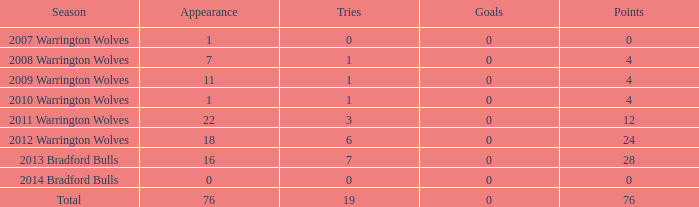What is the average number of tries for the 2008 warrington wolves with a presence exceeding 7? None. Write the full table. {'header': ['Season', 'Appearance', 'Tries', 'Goals', 'Points'], 'rows': [['2007 Warrington Wolves', '1', '0', '0', '0'], ['2008 Warrington Wolves', '7', '1', '0', '4'], ['2009 Warrington Wolves', '11', '1', '0', '4'], ['2010 Warrington Wolves', '1', '1', '0', '4'], ['2011 Warrington Wolves', '22', '3', '0', '12'], ['2012 Warrington Wolves', '18', '6', '0', '24'], ['2013 Bradford Bulls', '16', '7', '0', '28'], ['2014 Bradford Bulls', '0', '0', '0', '0'], ['Total', '76', '19', '0', '76']]} 